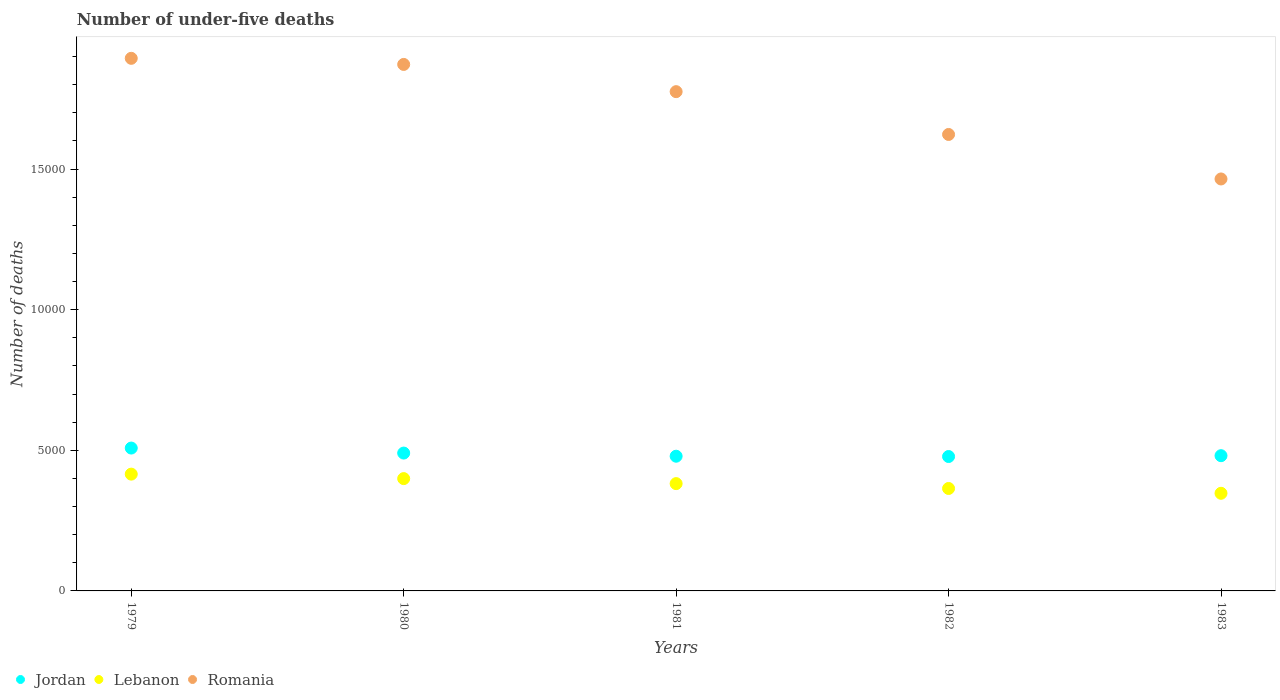How many different coloured dotlines are there?
Provide a short and direct response. 3. Is the number of dotlines equal to the number of legend labels?
Your answer should be very brief. Yes. What is the number of under-five deaths in Lebanon in 1982?
Offer a terse response. 3642. Across all years, what is the maximum number of under-five deaths in Jordan?
Provide a succinct answer. 5079. Across all years, what is the minimum number of under-five deaths in Lebanon?
Make the answer very short. 3471. In which year was the number of under-five deaths in Jordan maximum?
Keep it short and to the point. 1979. What is the total number of under-five deaths in Jordan in the graph?
Keep it short and to the point. 2.44e+04. What is the difference between the number of under-five deaths in Lebanon in 1979 and that in 1981?
Give a very brief answer. 337. What is the difference between the number of under-five deaths in Lebanon in 1981 and the number of under-five deaths in Jordan in 1982?
Provide a succinct answer. -963. What is the average number of under-five deaths in Lebanon per year?
Provide a short and direct response. 3814.6. In the year 1980, what is the difference between the number of under-five deaths in Jordan and number of under-five deaths in Lebanon?
Give a very brief answer. 908. What is the ratio of the number of under-five deaths in Romania in 1980 to that in 1983?
Give a very brief answer. 1.28. Is the difference between the number of under-five deaths in Jordan in 1979 and 1980 greater than the difference between the number of under-five deaths in Lebanon in 1979 and 1980?
Ensure brevity in your answer.  Yes. What is the difference between the highest and the second highest number of under-five deaths in Romania?
Offer a terse response. 217. What is the difference between the highest and the lowest number of under-five deaths in Romania?
Provide a short and direct response. 4289. Is the sum of the number of under-five deaths in Jordan in 1980 and 1983 greater than the maximum number of under-five deaths in Lebanon across all years?
Provide a succinct answer. Yes. Is it the case that in every year, the sum of the number of under-five deaths in Lebanon and number of under-five deaths in Romania  is greater than the number of under-five deaths in Jordan?
Give a very brief answer. Yes. Is the number of under-five deaths in Jordan strictly greater than the number of under-five deaths in Lebanon over the years?
Provide a succinct answer. Yes. Are the values on the major ticks of Y-axis written in scientific E-notation?
Your answer should be compact. No. Does the graph contain any zero values?
Keep it short and to the point. No. Where does the legend appear in the graph?
Give a very brief answer. Bottom left. How many legend labels are there?
Provide a short and direct response. 3. What is the title of the graph?
Provide a succinct answer. Number of under-five deaths. What is the label or title of the X-axis?
Your answer should be compact. Years. What is the label or title of the Y-axis?
Offer a terse response. Number of deaths. What is the Number of deaths in Jordan in 1979?
Keep it short and to the point. 5079. What is the Number of deaths in Lebanon in 1979?
Provide a short and direct response. 4152. What is the Number of deaths of Romania in 1979?
Your answer should be compact. 1.89e+04. What is the Number of deaths in Jordan in 1980?
Keep it short and to the point. 4901. What is the Number of deaths in Lebanon in 1980?
Offer a terse response. 3993. What is the Number of deaths in Romania in 1980?
Provide a short and direct response. 1.87e+04. What is the Number of deaths of Jordan in 1981?
Offer a terse response. 4789. What is the Number of deaths in Lebanon in 1981?
Provide a short and direct response. 3815. What is the Number of deaths in Romania in 1981?
Your answer should be very brief. 1.78e+04. What is the Number of deaths of Jordan in 1982?
Make the answer very short. 4778. What is the Number of deaths of Lebanon in 1982?
Your response must be concise. 3642. What is the Number of deaths in Romania in 1982?
Your answer should be compact. 1.62e+04. What is the Number of deaths of Jordan in 1983?
Keep it short and to the point. 4808. What is the Number of deaths in Lebanon in 1983?
Give a very brief answer. 3471. What is the Number of deaths of Romania in 1983?
Your answer should be very brief. 1.46e+04. Across all years, what is the maximum Number of deaths of Jordan?
Your answer should be compact. 5079. Across all years, what is the maximum Number of deaths of Lebanon?
Offer a terse response. 4152. Across all years, what is the maximum Number of deaths in Romania?
Ensure brevity in your answer.  1.89e+04. Across all years, what is the minimum Number of deaths in Jordan?
Offer a very short reply. 4778. Across all years, what is the minimum Number of deaths in Lebanon?
Give a very brief answer. 3471. Across all years, what is the minimum Number of deaths of Romania?
Give a very brief answer. 1.46e+04. What is the total Number of deaths of Jordan in the graph?
Provide a succinct answer. 2.44e+04. What is the total Number of deaths in Lebanon in the graph?
Give a very brief answer. 1.91e+04. What is the total Number of deaths in Romania in the graph?
Keep it short and to the point. 8.63e+04. What is the difference between the Number of deaths of Jordan in 1979 and that in 1980?
Your response must be concise. 178. What is the difference between the Number of deaths in Lebanon in 1979 and that in 1980?
Your answer should be compact. 159. What is the difference between the Number of deaths in Romania in 1979 and that in 1980?
Offer a terse response. 217. What is the difference between the Number of deaths of Jordan in 1979 and that in 1981?
Your answer should be compact. 290. What is the difference between the Number of deaths in Lebanon in 1979 and that in 1981?
Offer a very short reply. 337. What is the difference between the Number of deaths in Romania in 1979 and that in 1981?
Give a very brief answer. 1185. What is the difference between the Number of deaths of Jordan in 1979 and that in 1982?
Your answer should be compact. 301. What is the difference between the Number of deaths in Lebanon in 1979 and that in 1982?
Offer a very short reply. 510. What is the difference between the Number of deaths of Romania in 1979 and that in 1982?
Offer a very short reply. 2707. What is the difference between the Number of deaths of Jordan in 1979 and that in 1983?
Provide a short and direct response. 271. What is the difference between the Number of deaths in Lebanon in 1979 and that in 1983?
Your answer should be very brief. 681. What is the difference between the Number of deaths of Romania in 1979 and that in 1983?
Offer a very short reply. 4289. What is the difference between the Number of deaths of Jordan in 1980 and that in 1981?
Your answer should be compact. 112. What is the difference between the Number of deaths of Lebanon in 1980 and that in 1981?
Keep it short and to the point. 178. What is the difference between the Number of deaths of Romania in 1980 and that in 1981?
Your response must be concise. 968. What is the difference between the Number of deaths of Jordan in 1980 and that in 1982?
Give a very brief answer. 123. What is the difference between the Number of deaths of Lebanon in 1980 and that in 1982?
Provide a succinct answer. 351. What is the difference between the Number of deaths in Romania in 1980 and that in 1982?
Offer a terse response. 2490. What is the difference between the Number of deaths in Jordan in 1980 and that in 1983?
Make the answer very short. 93. What is the difference between the Number of deaths in Lebanon in 1980 and that in 1983?
Offer a very short reply. 522. What is the difference between the Number of deaths in Romania in 1980 and that in 1983?
Provide a short and direct response. 4072. What is the difference between the Number of deaths of Lebanon in 1981 and that in 1982?
Offer a very short reply. 173. What is the difference between the Number of deaths in Romania in 1981 and that in 1982?
Offer a terse response. 1522. What is the difference between the Number of deaths of Lebanon in 1981 and that in 1983?
Provide a succinct answer. 344. What is the difference between the Number of deaths of Romania in 1981 and that in 1983?
Offer a very short reply. 3104. What is the difference between the Number of deaths of Lebanon in 1982 and that in 1983?
Your response must be concise. 171. What is the difference between the Number of deaths in Romania in 1982 and that in 1983?
Provide a succinct answer. 1582. What is the difference between the Number of deaths in Jordan in 1979 and the Number of deaths in Lebanon in 1980?
Provide a succinct answer. 1086. What is the difference between the Number of deaths of Jordan in 1979 and the Number of deaths of Romania in 1980?
Your response must be concise. -1.36e+04. What is the difference between the Number of deaths in Lebanon in 1979 and the Number of deaths in Romania in 1980?
Keep it short and to the point. -1.46e+04. What is the difference between the Number of deaths in Jordan in 1979 and the Number of deaths in Lebanon in 1981?
Ensure brevity in your answer.  1264. What is the difference between the Number of deaths in Jordan in 1979 and the Number of deaths in Romania in 1981?
Give a very brief answer. -1.27e+04. What is the difference between the Number of deaths in Lebanon in 1979 and the Number of deaths in Romania in 1981?
Your response must be concise. -1.36e+04. What is the difference between the Number of deaths of Jordan in 1979 and the Number of deaths of Lebanon in 1982?
Give a very brief answer. 1437. What is the difference between the Number of deaths in Jordan in 1979 and the Number of deaths in Romania in 1982?
Provide a succinct answer. -1.11e+04. What is the difference between the Number of deaths in Lebanon in 1979 and the Number of deaths in Romania in 1982?
Give a very brief answer. -1.21e+04. What is the difference between the Number of deaths in Jordan in 1979 and the Number of deaths in Lebanon in 1983?
Your answer should be compact. 1608. What is the difference between the Number of deaths of Jordan in 1979 and the Number of deaths of Romania in 1983?
Keep it short and to the point. -9567. What is the difference between the Number of deaths in Lebanon in 1979 and the Number of deaths in Romania in 1983?
Provide a succinct answer. -1.05e+04. What is the difference between the Number of deaths in Jordan in 1980 and the Number of deaths in Lebanon in 1981?
Make the answer very short. 1086. What is the difference between the Number of deaths of Jordan in 1980 and the Number of deaths of Romania in 1981?
Your answer should be very brief. -1.28e+04. What is the difference between the Number of deaths in Lebanon in 1980 and the Number of deaths in Romania in 1981?
Offer a very short reply. -1.38e+04. What is the difference between the Number of deaths in Jordan in 1980 and the Number of deaths in Lebanon in 1982?
Make the answer very short. 1259. What is the difference between the Number of deaths in Jordan in 1980 and the Number of deaths in Romania in 1982?
Keep it short and to the point. -1.13e+04. What is the difference between the Number of deaths in Lebanon in 1980 and the Number of deaths in Romania in 1982?
Give a very brief answer. -1.22e+04. What is the difference between the Number of deaths in Jordan in 1980 and the Number of deaths in Lebanon in 1983?
Offer a terse response. 1430. What is the difference between the Number of deaths of Jordan in 1980 and the Number of deaths of Romania in 1983?
Keep it short and to the point. -9745. What is the difference between the Number of deaths in Lebanon in 1980 and the Number of deaths in Romania in 1983?
Make the answer very short. -1.07e+04. What is the difference between the Number of deaths of Jordan in 1981 and the Number of deaths of Lebanon in 1982?
Keep it short and to the point. 1147. What is the difference between the Number of deaths in Jordan in 1981 and the Number of deaths in Romania in 1982?
Your response must be concise. -1.14e+04. What is the difference between the Number of deaths of Lebanon in 1981 and the Number of deaths of Romania in 1982?
Your answer should be very brief. -1.24e+04. What is the difference between the Number of deaths of Jordan in 1981 and the Number of deaths of Lebanon in 1983?
Make the answer very short. 1318. What is the difference between the Number of deaths of Jordan in 1981 and the Number of deaths of Romania in 1983?
Provide a short and direct response. -9857. What is the difference between the Number of deaths in Lebanon in 1981 and the Number of deaths in Romania in 1983?
Provide a short and direct response. -1.08e+04. What is the difference between the Number of deaths in Jordan in 1982 and the Number of deaths in Lebanon in 1983?
Offer a very short reply. 1307. What is the difference between the Number of deaths of Jordan in 1982 and the Number of deaths of Romania in 1983?
Your answer should be compact. -9868. What is the difference between the Number of deaths of Lebanon in 1982 and the Number of deaths of Romania in 1983?
Offer a terse response. -1.10e+04. What is the average Number of deaths of Jordan per year?
Provide a succinct answer. 4871. What is the average Number of deaths in Lebanon per year?
Provide a short and direct response. 3814.6. What is the average Number of deaths of Romania per year?
Offer a very short reply. 1.73e+04. In the year 1979, what is the difference between the Number of deaths of Jordan and Number of deaths of Lebanon?
Make the answer very short. 927. In the year 1979, what is the difference between the Number of deaths in Jordan and Number of deaths in Romania?
Keep it short and to the point. -1.39e+04. In the year 1979, what is the difference between the Number of deaths in Lebanon and Number of deaths in Romania?
Give a very brief answer. -1.48e+04. In the year 1980, what is the difference between the Number of deaths of Jordan and Number of deaths of Lebanon?
Provide a succinct answer. 908. In the year 1980, what is the difference between the Number of deaths in Jordan and Number of deaths in Romania?
Keep it short and to the point. -1.38e+04. In the year 1980, what is the difference between the Number of deaths in Lebanon and Number of deaths in Romania?
Provide a short and direct response. -1.47e+04. In the year 1981, what is the difference between the Number of deaths in Jordan and Number of deaths in Lebanon?
Ensure brevity in your answer.  974. In the year 1981, what is the difference between the Number of deaths in Jordan and Number of deaths in Romania?
Your response must be concise. -1.30e+04. In the year 1981, what is the difference between the Number of deaths of Lebanon and Number of deaths of Romania?
Provide a short and direct response. -1.39e+04. In the year 1982, what is the difference between the Number of deaths of Jordan and Number of deaths of Lebanon?
Offer a terse response. 1136. In the year 1982, what is the difference between the Number of deaths of Jordan and Number of deaths of Romania?
Provide a short and direct response. -1.14e+04. In the year 1982, what is the difference between the Number of deaths in Lebanon and Number of deaths in Romania?
Ensure brevity in your answer.  -1.26e+04. In the year 1983, what is the difference between the Number of deaths of Jordan and Number of deaths of Lebanon?
Your response must be concise. 1337. In the year 1983, what is the difference between the Number of deaths in Jordan and Number of deaths in Romania?
Provide a succinct answer. -9838. In the year 1983, what is the difference between the Number of deaths of Lebanon and Number of deaths of Romania?
Keep it short and to the point. -1.12e+04. What is the ratio of the Number of deaths of Jordan in 1979 to that in 1980?
Offer a very short reply. 1.04. What is the ratio of the Number of deaths in Lebanon in 1979 to that in 1980?
Provide a short and direct response. 1.04. What is the ratio of the Number of deaths of Romania in 1979 to that in 1980?
Provide a succinct answer. 1.01. What is the ratio of the Number of deaths in Jordan in 1979 to that in 1981?
Provide a short and direct response. 1.06. What is the ratio of the Number of deaths in Lebanon in 1979 to that in 1981?
Your answer should be compact. 1.09. What is the ratio of the Number of deaths in Romania in 1979 to that in 1981?
Keep it short and to the point. 1.07. What is the ratio of the Number of deaths of Jordan in 1979 to that in 1982?
Your answer should be compact. 1.06. What is the ratio of the Number of deaths of Lebanon in 1979 to that in 1982?
Give a very brief answer. 1.14. What is the ratio of the Number of deaths in Romania in 1979 to that in 1982?
Your answer should be very brief. 1.17. What is the ratio of the Number of deaths in Jordan in 1979 to that in 1983?
Offer a terse response. 1.06. What is the ratio of the Number of deaths in Lebanon in 1979 to that in 1983?
Provide a succinct answer. 1.2. What is the ratio of the Number of deaths in Romania in 1979 to that in 1983?
Provide a short and direct response. 1.29. What is the ratio of the Number of deaths in Jordan in 1980 to that in 1981?
Offer a terse response. 1.02. What is the ratio of the Number of deaths of Lebanon in 1980 to that in 1981?
Make the answer very short. 1.05. What is the ratio of the Number of deaths in Romania in 1980 to that in 1981?
Keep it short and to the point. 1.05. What is the ratio of the Number of deaths in Jordan in 1980 to that in 1982?
Give a very brief answer. 1.03. What is the ratio of the Number of deaths of Lebanon in 1980 to that in 1982?
Keep it short and to the point. 1.1. What is the ratio of the Number of deaths of Romania in 1980 to that in 1982?
Make the answer very short. 1.15. What is the ratio of the Number of deaths of Jordan in 1980 to that in 1983?
Provide a short and direct response. 1.02. What is the ratio of the Number of deaths of Lebanon in 1980 to that in 1983?
Offer a terse response. 1.15. What is the ratio of the Number of deaths of Romania in 1980 to that in 1983?
Your response must be concise. 1.28. What is the ratio of the Number of deaths in Jordan in 1981 to that in 1982?
Keep it short and to the point. 1. What is the ratio of the Number of deaths in Lebanon in 1981 to that in 1982?
Offer a very short reply. 1.05. What is the ratio of the Number of deaths in Romania in 1981 to that in 1982?
Keep it short and to the point. 1.09. What is the ratio of the Number of deaths in Jordan in 1981 to that in 1983?
Offer a very short reply. 1. What is the ratio of the Number of deaths of Lebanon in 1981 to that in 1983?
Offer a very short reply. 1.1. What is the ratio of the Number of deaths of Romania in 1981 to that in 1983?
Provide a short and direct response. 1.21. What is the ratio of the Number of deaths in Lebanon in 1982 to that in 1983?
Give a very brief answer. 1.05. What is the ratio of the Number of deaths in Romania in 1982 to that in 1983?
Provide a short and direct response. 1.11. What is the difference between the highest and the second highest Number of deaths in Jordan?
Make the answer very short. 178. What is the difference between the highest and the second highest Number of deaths of Lebanon?
Ensure brevity in your answer.  159. What is the difference between the highest and the second highest Number of deaths of Romania?
Make the answer very short. 217. What is the difference between the highest and the lowest Number of deaths in Jordan?
Provide a short and direct response. 301. What is the difference between the highest and the lowest Number of deaths in Lebanon?
Your answer should be very brief. 681. What is the difference between the highest and the lowest Number of deaths of Romania?
Offer a terse response. 4289. 